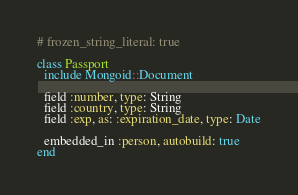Convert code to text. <code><loc_0><loc_0><loc_500><loc_500><_Ruby_># frozen_string_literal: true

class Passport
  include Mongoid::Document

  field :number, type: String
  field :country, type: String
  field :exp, as: :expiration_date, type: Date

  embedded_in :person, autobuild: true
end
</code> 